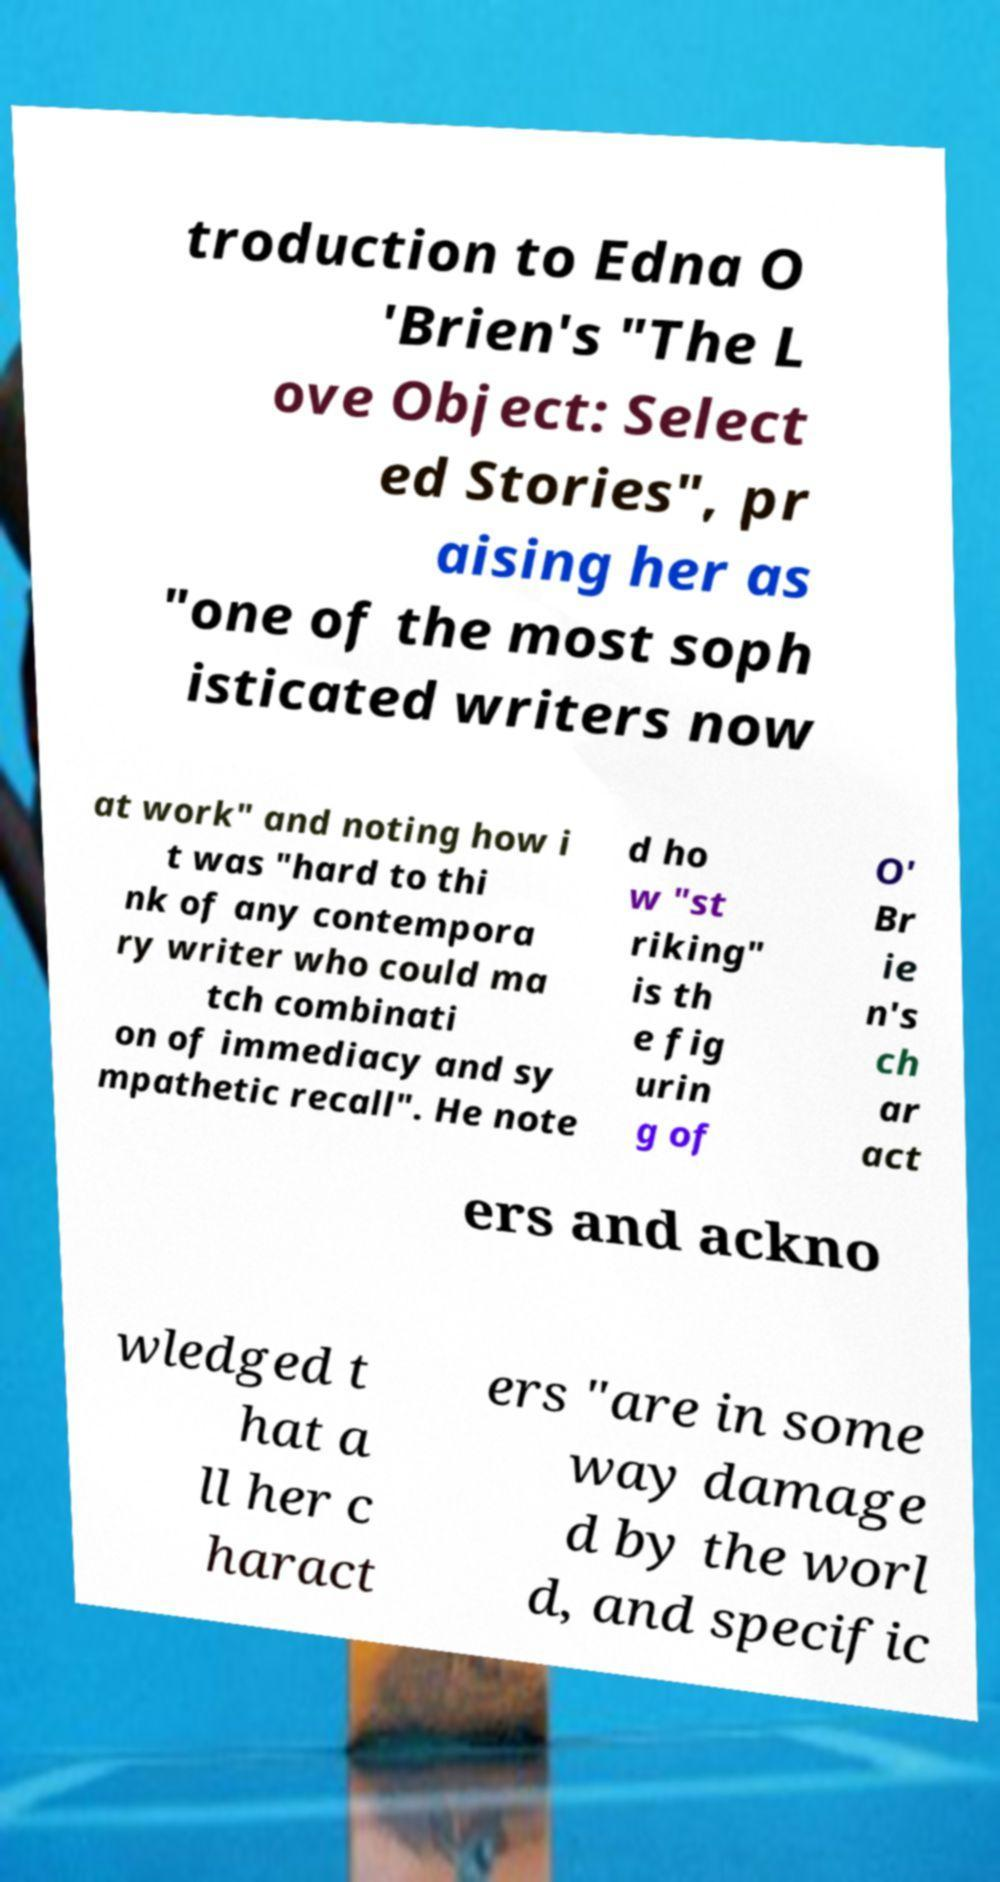There's text embedded in this image that I need extracted. Can you transcribe it verbatim? troduction to Edna O 'Brien's "The L ove Object: Select ed Stories", pr aising her as "one of the most soph isticated writers now at work" and noting how i t was "hard to thi nk of any contempora ry writer who could ma tch combinati on of immediacy and sy mpathetic recall". He note d ho w "st riking" is th e fig urin g of O' Br ie n's ch ar act ers and ackno wledged t hat a ll her c haract ers "are in some way damage d by the worl d, and specific 